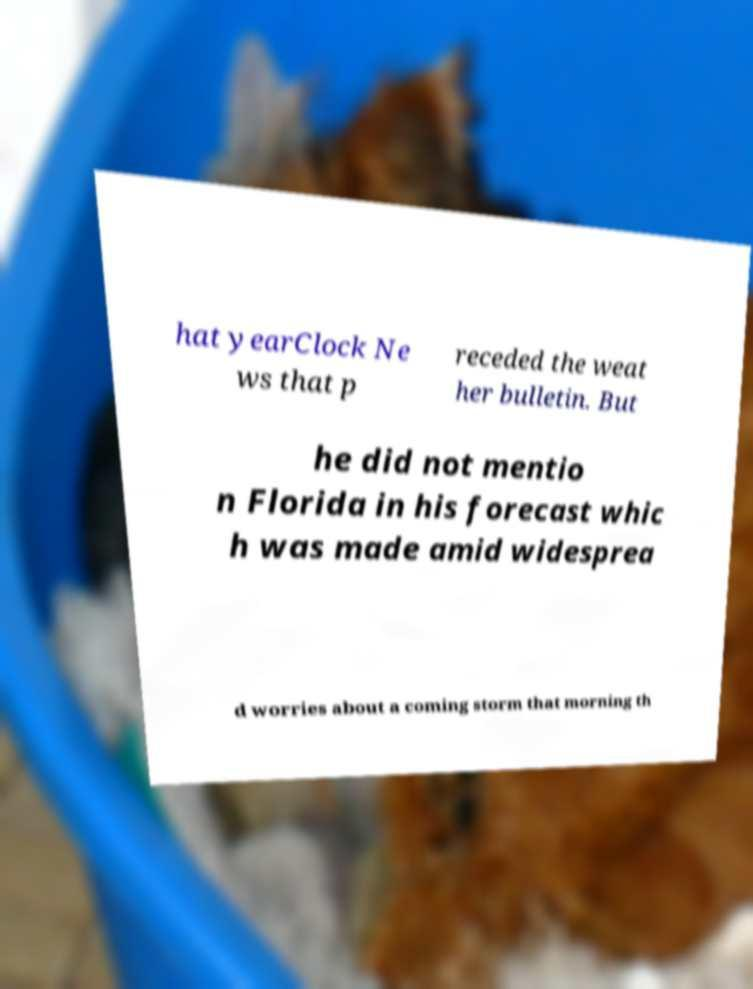Can you read and provide the text displayed in the image?This photo seems to have some interesting text. Can you extract and type it out for me? hat yearClock Ne ws that p receded the weat her bulletin. But he did not mentio n Florida in his forecast whic h was made amid widesprea d worries about a coming storm that morning th 